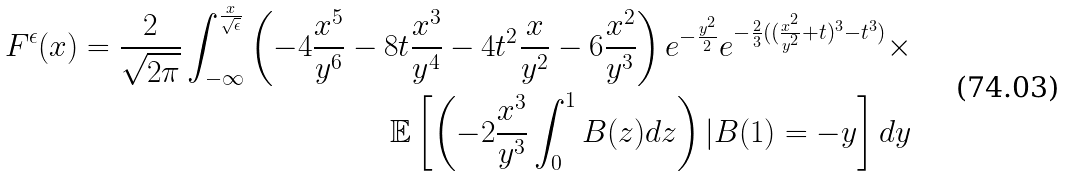Convert formula to latex. <formula><loc_0><loc_0><loc_500><loc_500>F ^ { \epsilon } ( x ) = \frac { 2 } { \sqrt { 2 \pi } } \int _ { - \infty } ^ { \frac { x } { \sqrt { \epsilon } } } \left ( - 4 \frac { x ^ { 5 } } { y ^ { 6 } } - 8 t \frac { x ^ { 3 } } { y ^ { 4 } } - 4 t ^ { 2 } \frac { x } { y ^ { 2 } } - 6 \frac { x ^ { 2 } } { y ^ { 3 } } \right ) e ^ { - \frac { y ^ { 2 } } { 2 } } e ^ { - \frac { 2 } { 3 } ( ( \frac { x ^ { 2 } } { y ^ { 2 } } + t ) ^ { 3 } - t ^ { 3 } ) } \times \\ \mathbb { E } \left [ \left ( - 2 \frac { x ^ { 3 } } { y ^ { 3 } } \int _ { 0 } ^ { 1 } B ( z ) d z \right ) | B ( 1 ) = - y \right ] d y</formula> 